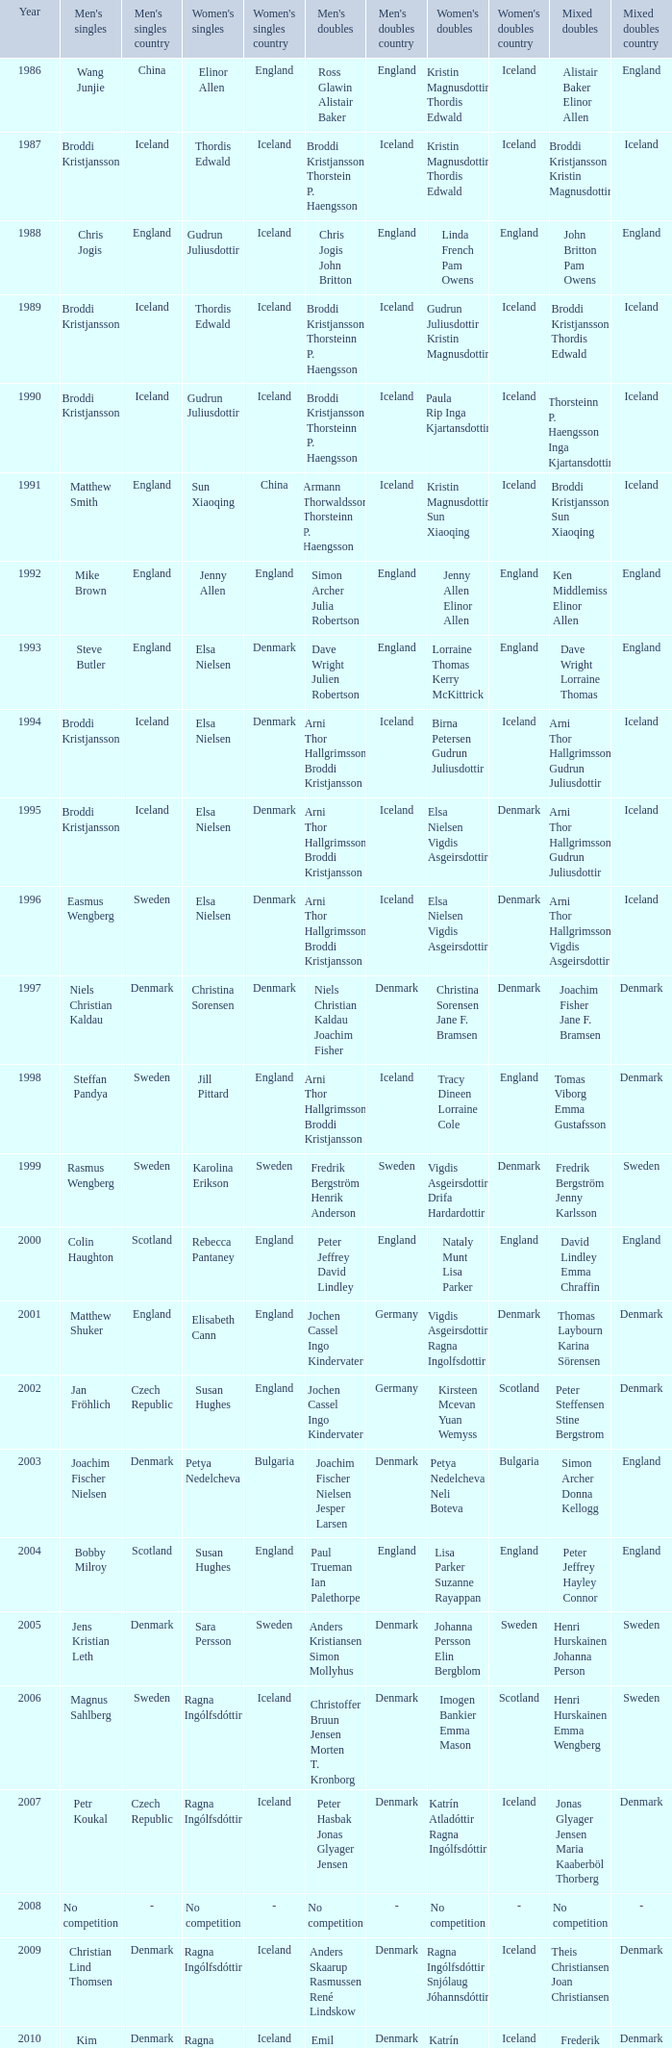Which mixed doubles happened later than 2011? Chou Tien-chen Chiang Mei-hui. 